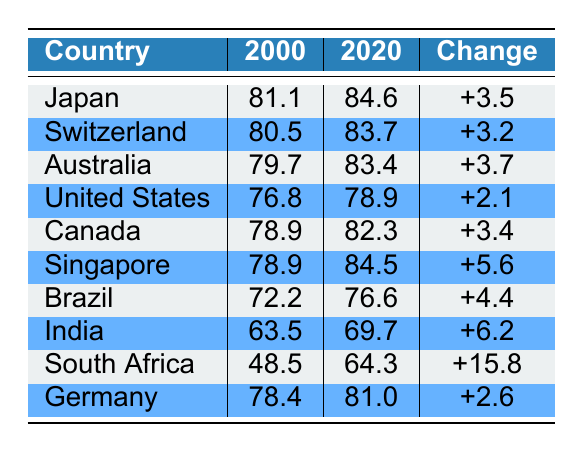What is the life expectancy of Japan in 2020? The table shows that Japan's life expectancy in 2020 is listed directly under the "2020" column for Japan. It is read as 84.6.
Answer: 84.6 Which country had the highest increase in life expectancy from 2000 to 2020? To find the country with the highest increase, we calculate the change for each country by comparing their 2020 and 2000 life expectancies. South Africa shows the largest increase of +15.8.
Answer: South Africa What is the average life expectancy in 2000 for the countries listed? We sum the life expectancies of each country in 2000: (81.1 + 80.5 + 79.7 + 76.8 + 78.9 + 78.9 + 72.2 + 63.5 + 48.5 + 78.4) = 792.0. Then, we divide by the number of countries (10): 792.0 / 10 = 79.2.
Answer: 79.2 Did every country listed increase their life expectancy by more than 2 years from 2000 to 2020? By checking the changes for each country, we see that all countries, except for the United States, India, and Germany, experienced increases greater than 2 years. Therefore, the statement is false.
Answer: No Which country had a life expectancy of over 80 years in both 2000 and 2020? We look for countries in both columns who have values greater than 80. Japan and Switzerland are the only countries that meet this criterion in both years.
Answer: Japan, Switzerland What is the total change in life expectancy across all countries from 2000 to 2020? We sum all the changes in life expectancy: (3.5 + 3.2 + 3.7 + 2.1 + 3.4 + 5.6 + 4.4 + 6.2 + 15.8 + 2.6) = 46.5.
Answer: 46.5 Which country had the lowest life expectancy in 2000? By looking at the 2000 column, we find the lowest value is 48.5 for South Africa.
Answer: South Africa Is it true that Singapore's life expectancy increased by more than 5 years from 2000 to 2020? We calculate the increase for Singapore: 84.5 - 78.9 = 5.6. Since this is indeed more than 5, the statement is true.
Answer: Yes 